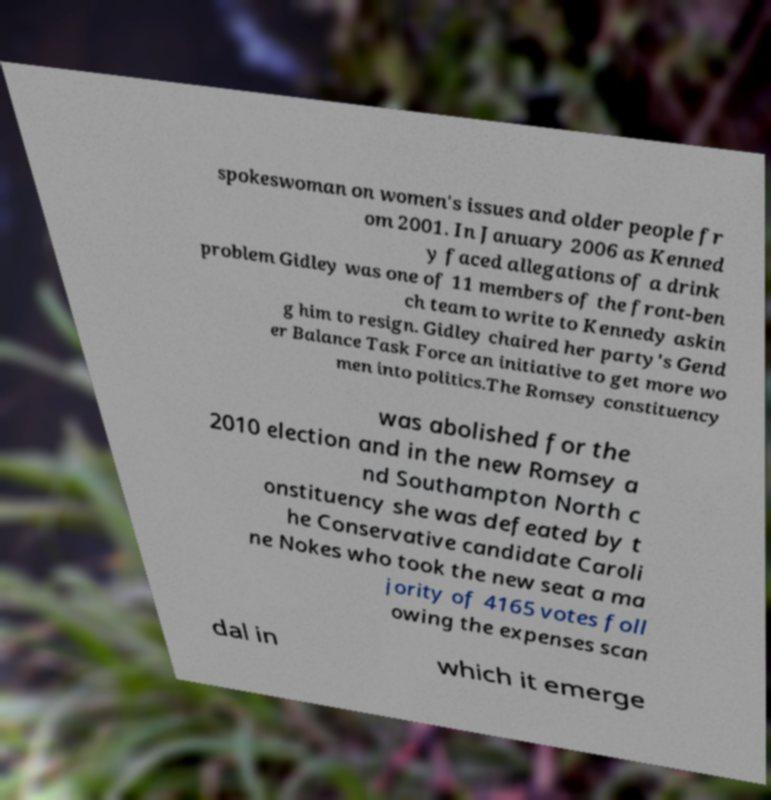Can you read and provide the text displayed in the image?This photo seems to have some interesting text. Can you extract and type it out for me? spokeswoman on women's issues and older people fr om 2001. In January 2006 as Kenned y faced allegations of a drink problem Gidley was one of 11 members of the front-ben ch team to write to Kennedy askin g him to resign. Gidley chaired her party's Gend er Balance Task Force an initiative to get more wo men into politics.The Romsey constituency was abolished for the 2010 election and in the new Romsey a nd Southampton North c onstituency she was defeated by t he Conservative candidate Caroli ne Nokes who took the new seat a ma jority of 4165 votes foll owing the expenses scan dal in which it emerge 